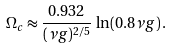Convert formula to latex. <formula><loc_0><loc_0><loc_500><loc_500>\Omega _ { c } \approx \frac { 0 . 9 3 2 } { ( \nu g ) ^ { 2 / 5 } } \, \ln ( 0 . 8 \nu g ) \, .</formula> 